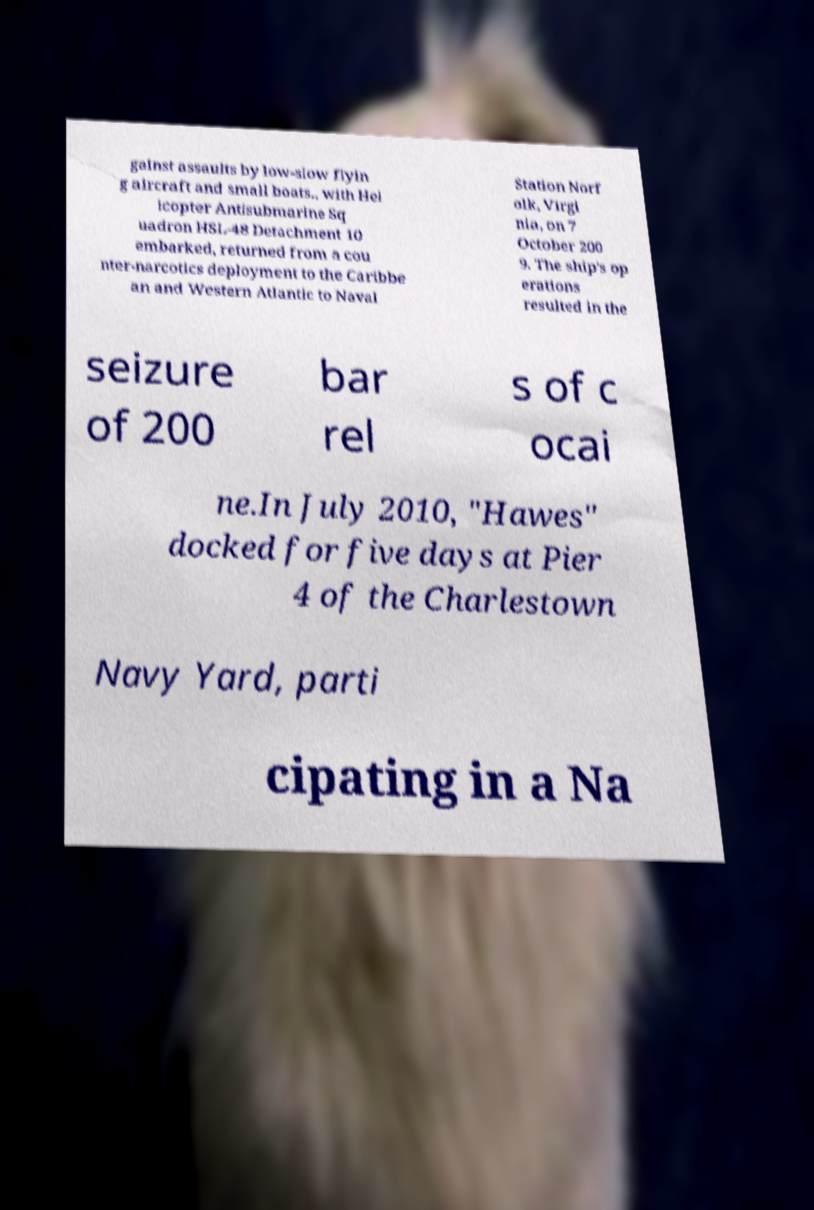Could you assist in decoding the text presented in this image and type it out clearly? gainst assaults by low-slow flyin g aircraft and small boats., with Hel icopter Antisubmarine Sq uadron HSL-48 Detachment 10 embarked, returned from a cou nter-narcotics deployment to the Caribbe an and Western Atlantic to Naval Station Norf olk, Virgi nia, on 7 October 200 9. The ship's op erations resulted in the seizure of 200 bar rel s of c ocai ne.In July 2010, "Hawes" docked for five days at Pier 4 of the Charlestown Navy Yard, parti cipating in a Na 